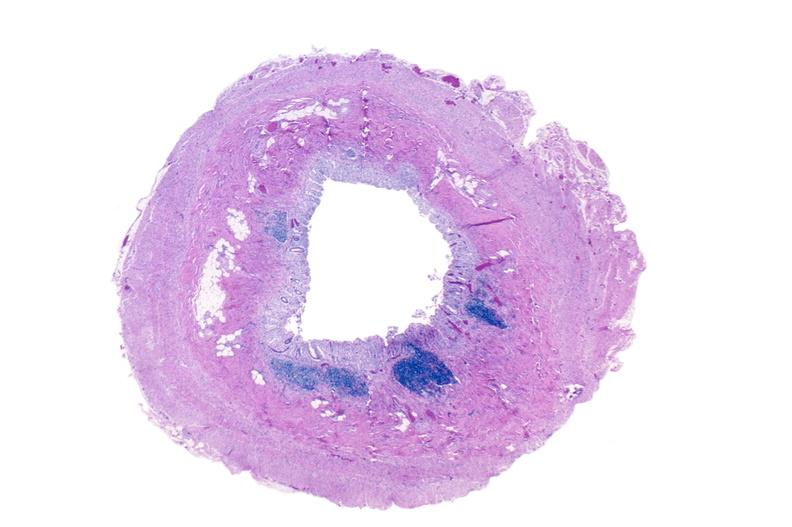does breast show normal appendix?
Answer the question using a single word or phrase. No 